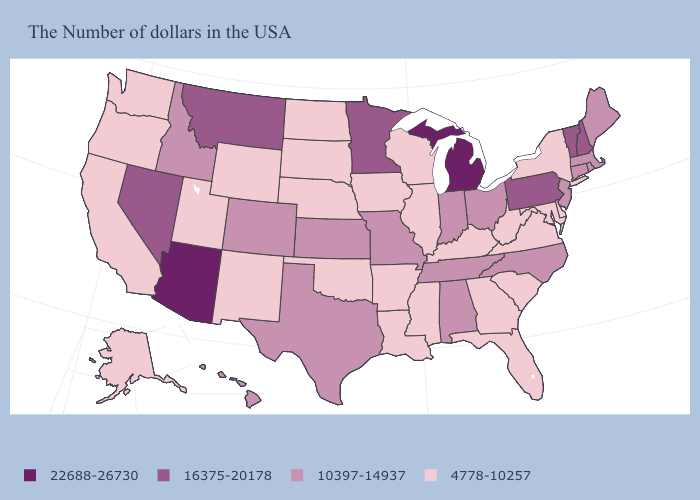Name the states that have a value in the range 4778-10257?
Keep it brief. New York, Delaware, Maryland, Virginia, South Carolina, West Virginia, Florida, Georgia, Kentucky, Wisconsin, Illinois, Mississippi, Louisiana, Arkansas, Iowa, Nebraska, Oklahoma, South Dakota, North Dakota, Wyoming, New Mexico, Utah, California, Washington, Oregon, Alaska. Which states have the lowest value in the West?
Quick response, please. Wyoming, New Mexico, Utah, California, Washington, Oregon, Alaska. Among the states that border Mississippi , which have the lowest value?
Short answer required. Louisiana, Arkansas. What is the value of Montana?
Quick response, please. 16375-20178. Which states have the lowest value in the West?
Give a very brief answer. Wyoming, New Mexico, Utah, California, Washington, Oregon, Alaska. What is the value of North Carolina?
Quick response, please. 10397-14937. What is the value of Kentucky?
Quick response, please. 4778-10257. What is the lowest value in the West?
Keep it brief. 4778-10257. Name the states that have a value in the range 10397-14937?
Short answer required. Maine, Massachusetts, Rhode Island, Connecticut, New Jersey, North Carolina, Ohio, Indiana, Alabama, Tennessee, Missouri, Kansas, Texas, Colorado, Idaho, Hawaii. What is the value of Georgia?
Write a very short answer. 4778-10257. Name the states that have a value in the range 22688-26730?
Give a very brief answer. Michigan, Arizona. Does South Dakota have a lower value than Alabama?
Write a very short answer. Yes. What is the value of Nevada?
Quick response, please. 16375-20178. What is the value of Washington?
Answer briefly. 4778-10257. What is the lowest value in states that border Tennessee?
Answer briefly. 4778-10257. 